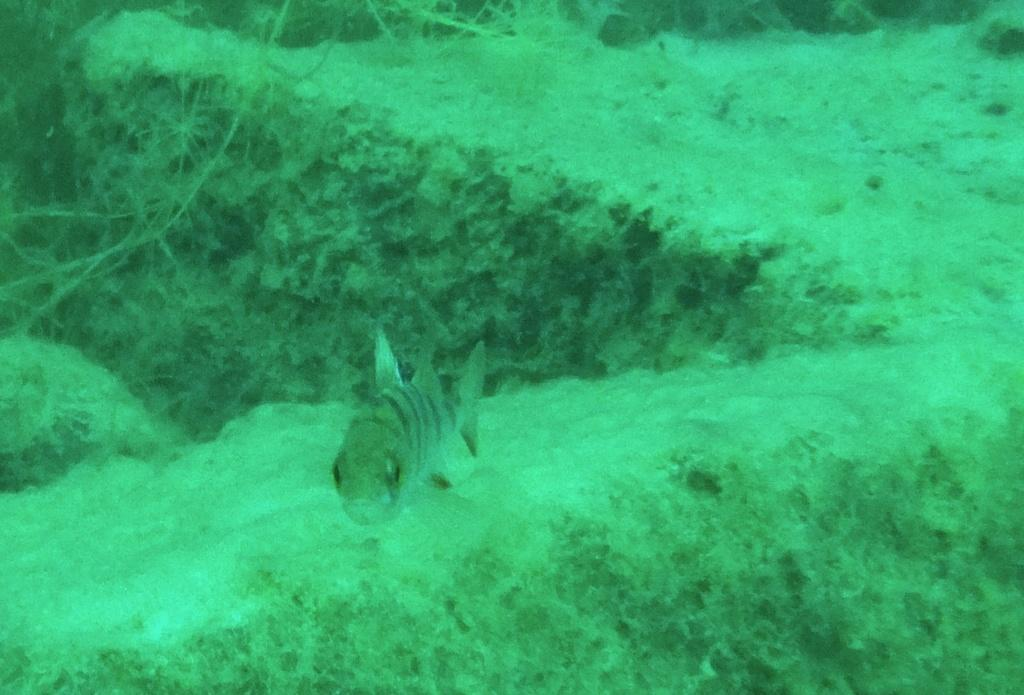What type of animal is in the image? There is a fish in the image. What environment is the fish in? The fish is in marine water. How many babies are buried in the cemetery in the image? There is no cemetery or babies present in the image; it features a fish in marine water. 